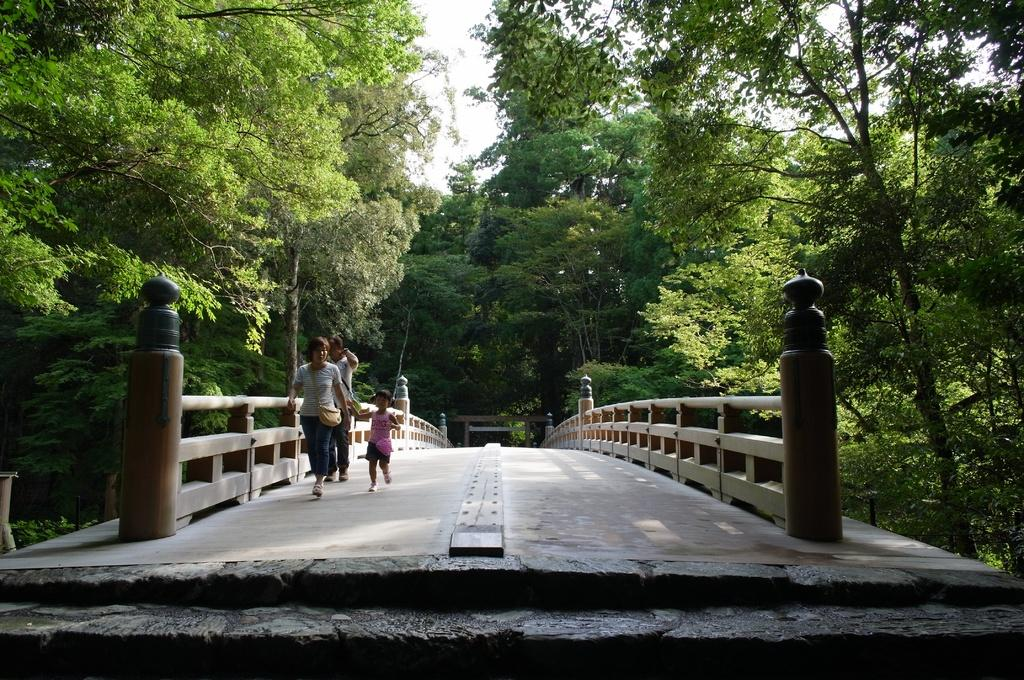What type of structure is in the image? There is a walkway bridge in the image. What are the people in the image doing? Three people are walking on the bridge. What can be seen in the background of the image? There is sky and trees visible in the background. What type of tomatoes can be seen playing music on the bridge in the image? There are no tomatoes or musical instruments present in the image; it features a walkway bridge with three people walking on it. 